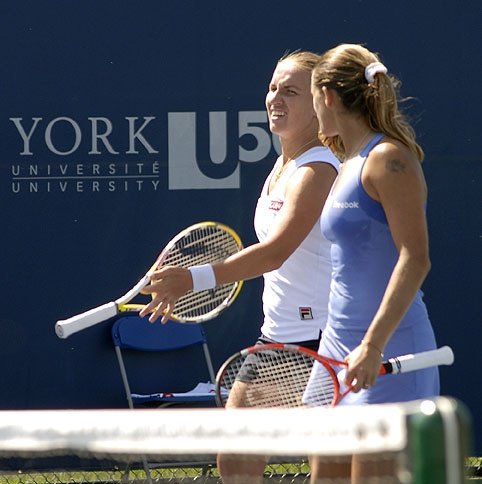Describe the objects in this image and their specific colors. I can see people in navy, white, blue, maroon, and gray tones, people in navy, gray, white, darkgray, and brown tones, tennis racket in navy, darkgray, gray, lightgray, and brown tones, chair in navy, black, gray, and darkgray tones, and tennis racket in navy, gray, black, darkgray, and white tones in this image. 